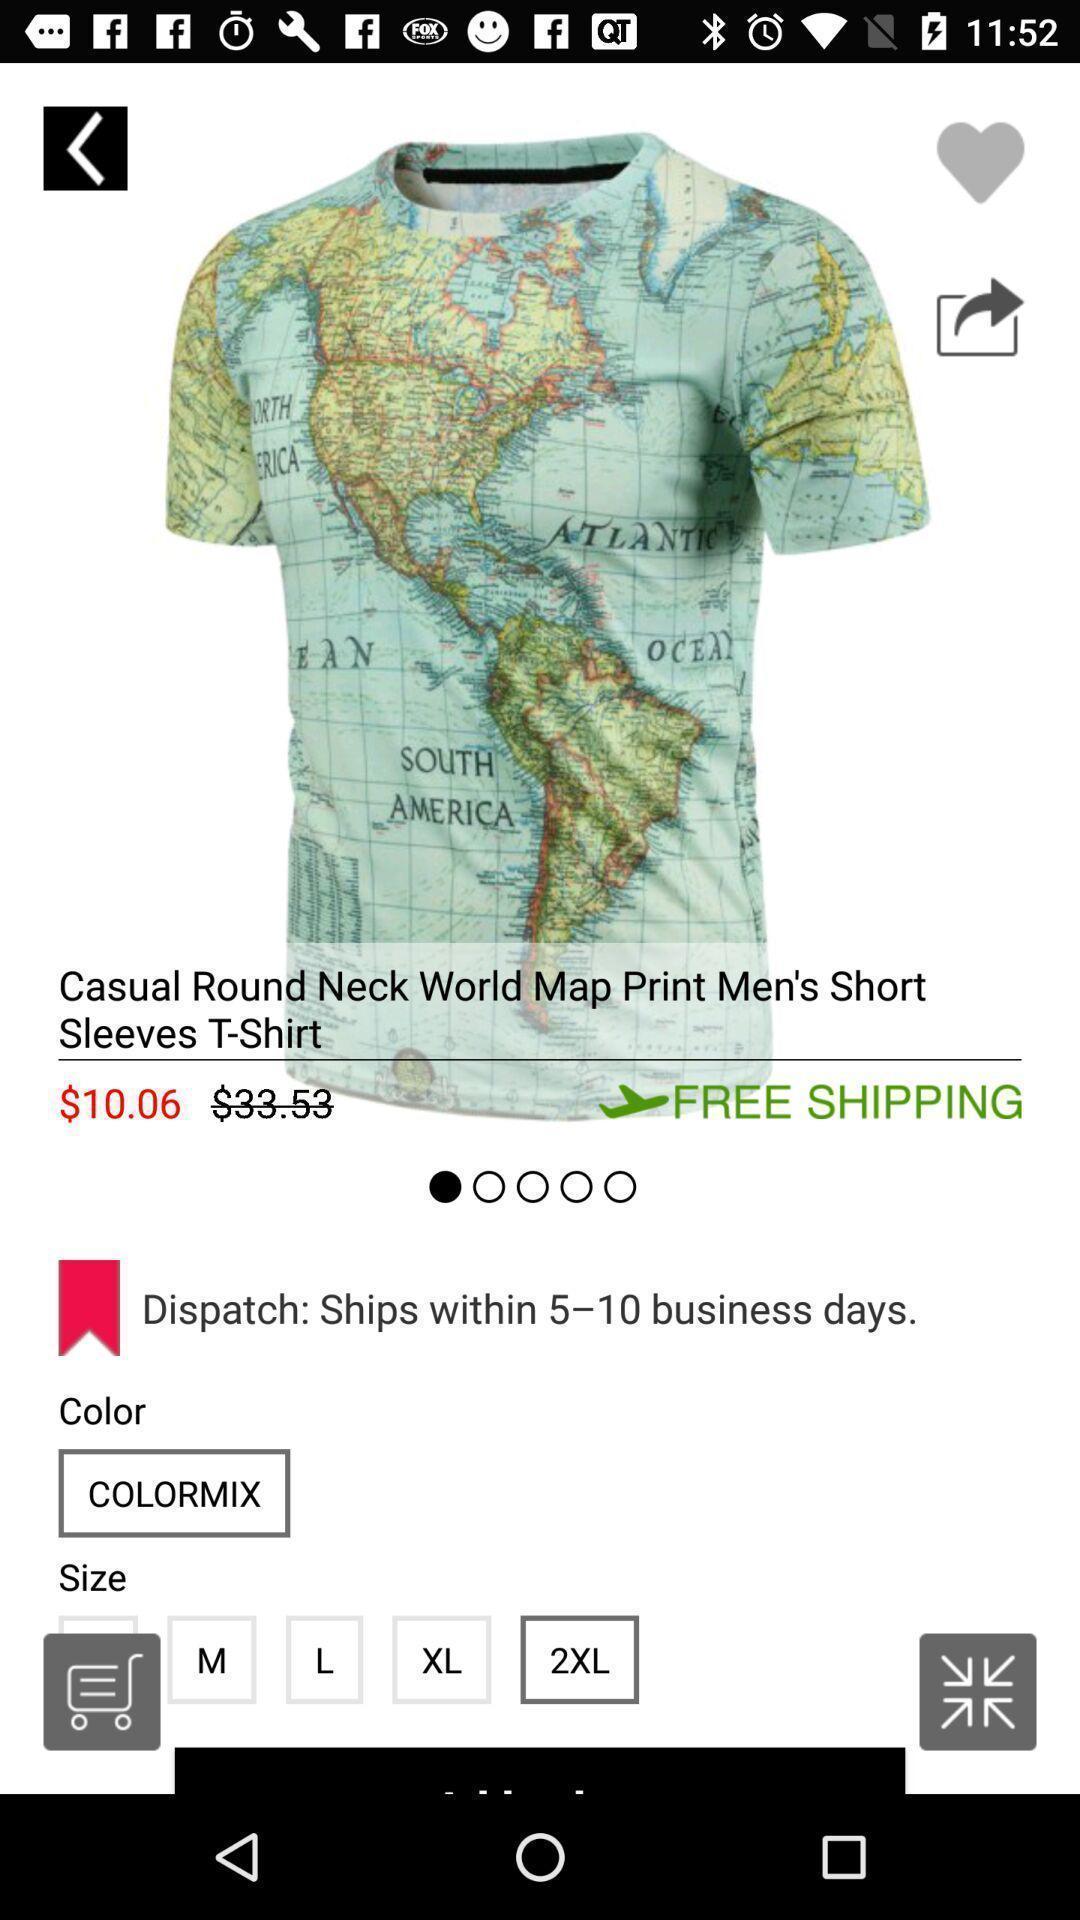Provide a textual representation of this image. Screen showing a product in a shopping app. 